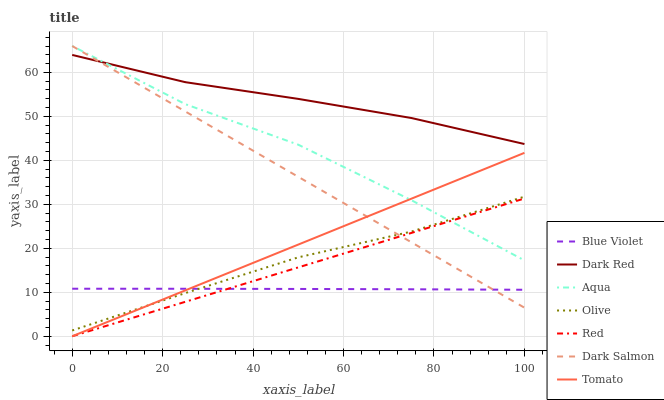Does Blue Violet have the minimum area under the curve?
Answer yes or no. Yes. Does Dark Red have the maximum area under the curve?
Answer yes or no. Yes. Does Aqua have the minimum area under the curve?
Answer yes or no. No. Does Aqua have the maximum area under the curve?
Answer yes or no. No. Is Red the smoothest?
Answer yes or no. Yes. Is Aqua the roughest?
Answer yes or no. Yes. Is Dark Red the smoothest?
Answer yes or no. No. Is Dark Red the roughest?
Answer yes or no. No. Does Aqua have the lowest value?
Answer yes or no. No. Does Dark Red have the highest value?
Answer yes or no. No. Is Tomato less than Dark Red?
Answer yes or no. Yes. Is Dark Red greater than Olive?
Answer yes or no. Yes. Does Tomato intersect Dark Red?
Answer yes or no. No. 